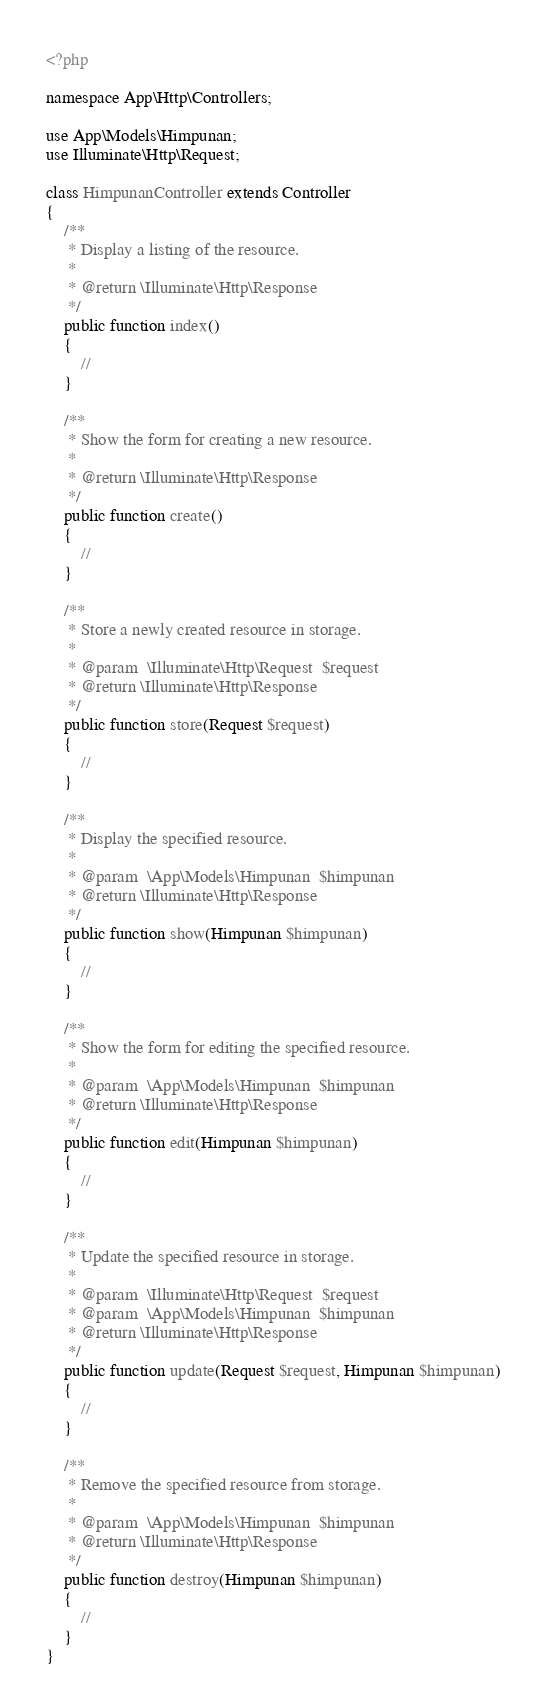Convert code to text. <code><loc_0><loc_0><loc_500><loc_500><_PHP_><?php

namespace App\Http\Controllers;

use App\Models\Himpunan;
use Illuminate\Http\Request;

class HimpunanController extends Controller
{
    /**
     * Display a listing of the resource.
     *
     * @return \Illuminate\Http\Response
     */
    public function index()
    {
        //
    }

    /**
     * Show the form for creating a new resource.
     *
     * @return \Illuminate\Http\Response
     */
    public function create()
    {
        //
    }

    /**
     * Store a newly created resource in storage.
     *
     * @param  \Illuminate\Http\Request  $request
     * @return \Illuminate\Http\Response
     */
    public function store(Request $request)
    {
        //
    }

    /**
     * Display the specified resource.
     *
     * @param  \App\Models\Himpunan  $himpunan
     * @return \Illuminate\Http\Response
     */
    public function show(Himpunan $himpunan)
    {
        //
    }

    /**
     * Show the form for editing the specified resource.
     *
     * @param  \App\Models\Himpunan  $himpunan
     * @return \Illuminate\Http\Response
     */
    public function edit(Himpunan $himpunan)
    {
        //
    }

    /**
     * Update the specified resource in storage.
     *
     * @param  \Illuminate\Http\Request  $request
     * @param  \App\Models\Himpunan  $himpunan
     * @return \Illuminate\Http\Response
     */
    public function update(Request $request, Himpunan $himpunan)
    {
        //
    }

    /**
     * Remove the specified resource from storage.
     *
     * @param  \App\Models\Himpunan  $himpunan
     * @return \Illuminate\Http\Response
     */
    public function destroy(Himpunan $himpunan)
    {
        //
    }
}
</code> 